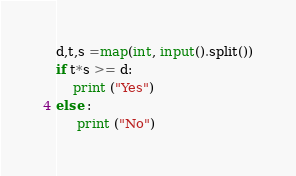<code> <loc_0><loc_0><loc_500><loc_500><_Python_>d,t,s =map(int, input().split())
if t*s >= d:
    print ("Yes")
else :
     print ("No")

</code> 